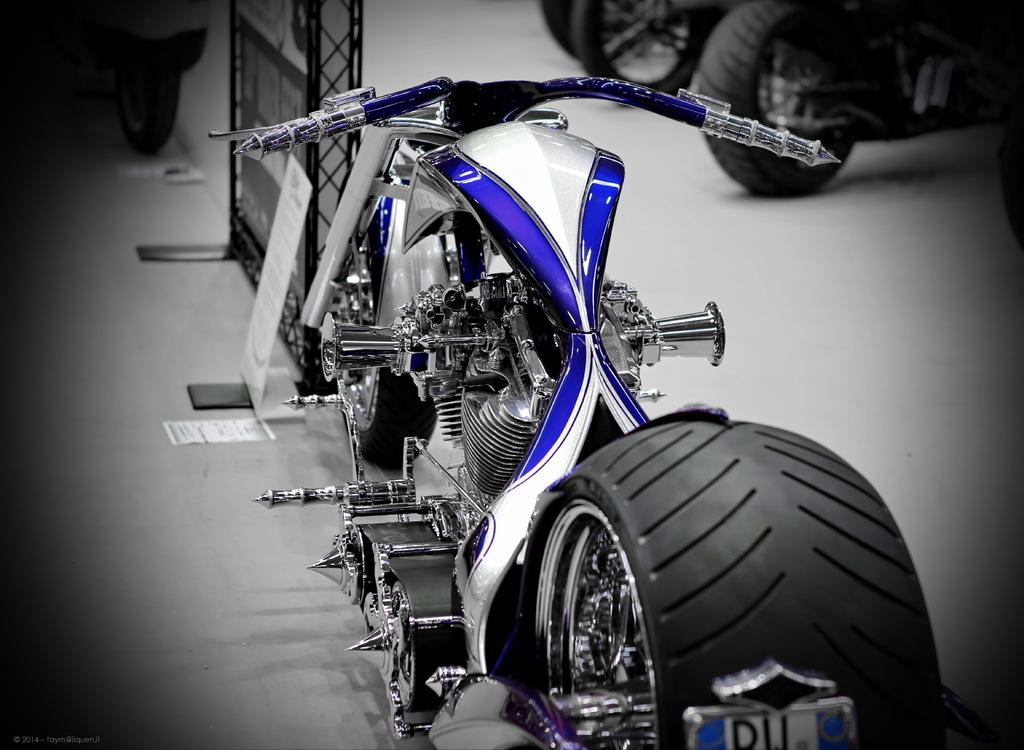What is the main object in the image? There is a bike in the image. What else can be seen in the image besides the bike? There is a board and papers in the image. Are there any objects related to transportation in the image? Yes, there are wheels of vehicles on the floor in the image. How does the society depicted in the image react to the sleet falling outside? There is no depiction of society or sleet in the image; it only features a bike, a board, papers, and wheels of vehicles. 